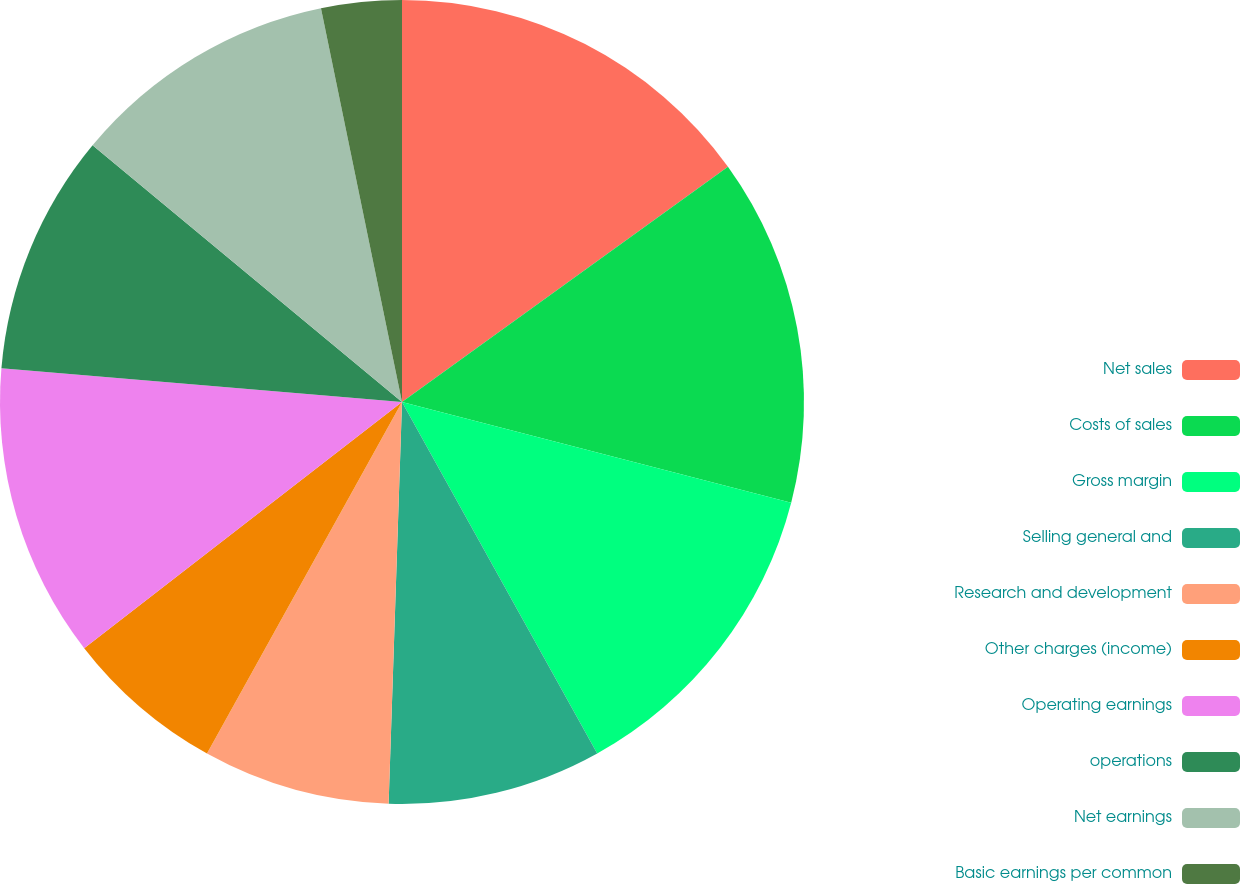Convert chart. <chart><loc_0><loc_0><loc_500><loc_500><pie_chart><fcel>Net sales<fcel>Costs of sales<fcel>Gross margin<fcel>Selling general and<fcel>Research and development<fcel>Other charges (income)<fcel>Operating earnings<fcel>operations<fcel>Net earnings<fcel>Basic earnings per common<nl><fcel>15.05%<fcel>13.98%<fcel>12.9%<fcel>8.6%<fcel>7.53%<fcel>6.45%<fcel>11.83%<fcel>9.68%<fcel>10.75%<fcel>3.23%<nl></chart> 